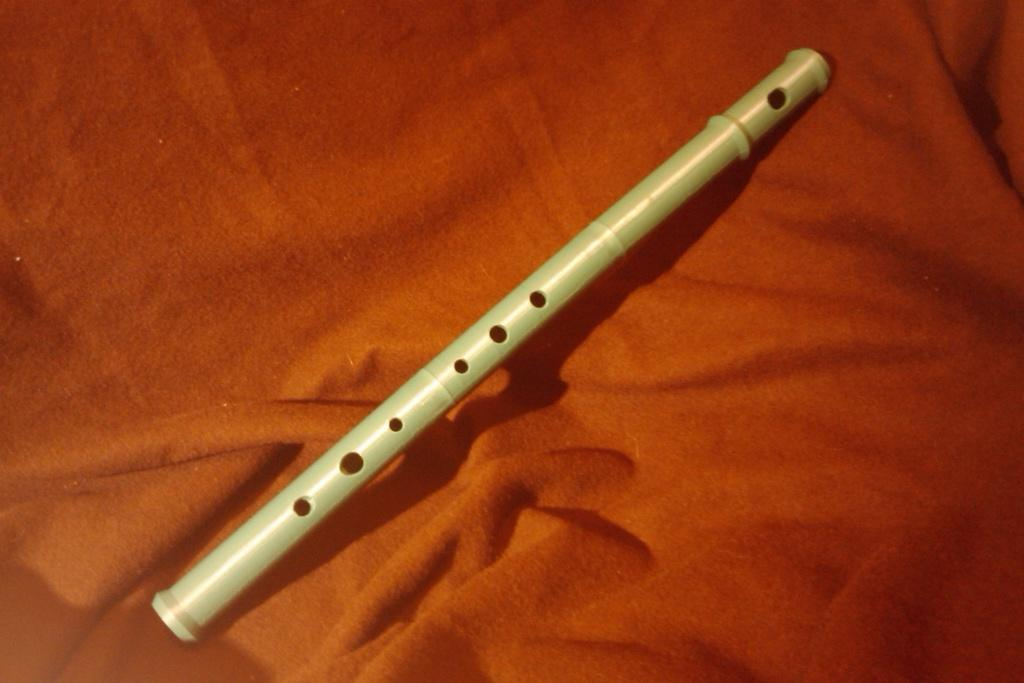What musical instrument is present in the image? There is a flute in the image. What is the flute placed on? The flute is on a cloth. Where is the flute located in the image? The flute is located in the center of the image. What type of action is the flute performing in the image? The flute is not performing any action in the image; it is simply placed on a cloth. 